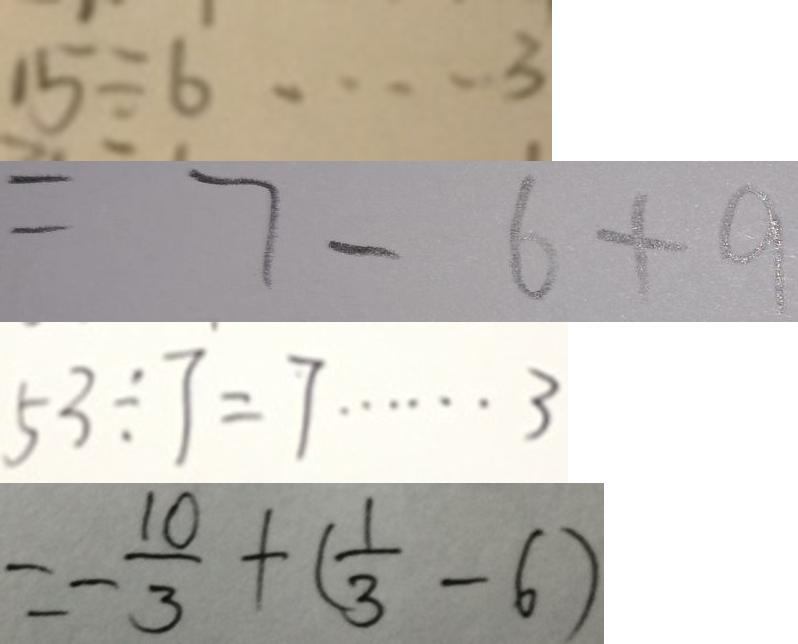<formula> <loc_0><loc_0><loc_500><loc_500>1 5 \div 6 \cdots 3 
 = 7 - 6 + 9 
 5 3 \div 7 = 7 \cdots 3 
 = - \frac { 1 0 } { 3 } + ( \frac { 1 } { 3 } - 6 )</formula> 